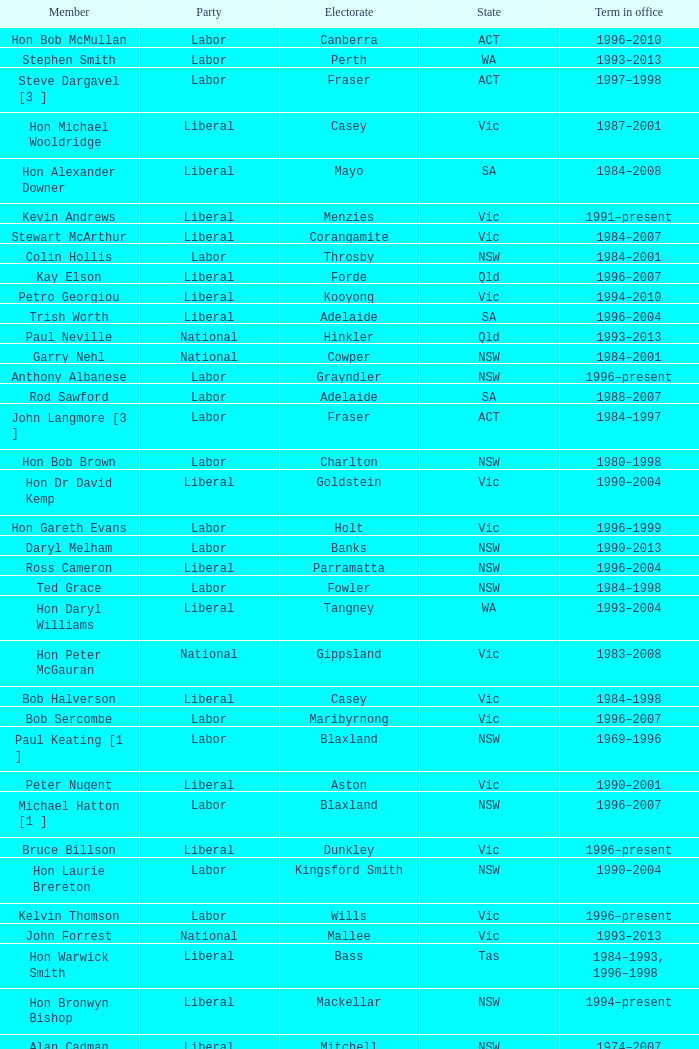What state did Hon David Beddall belong to? Qld. 